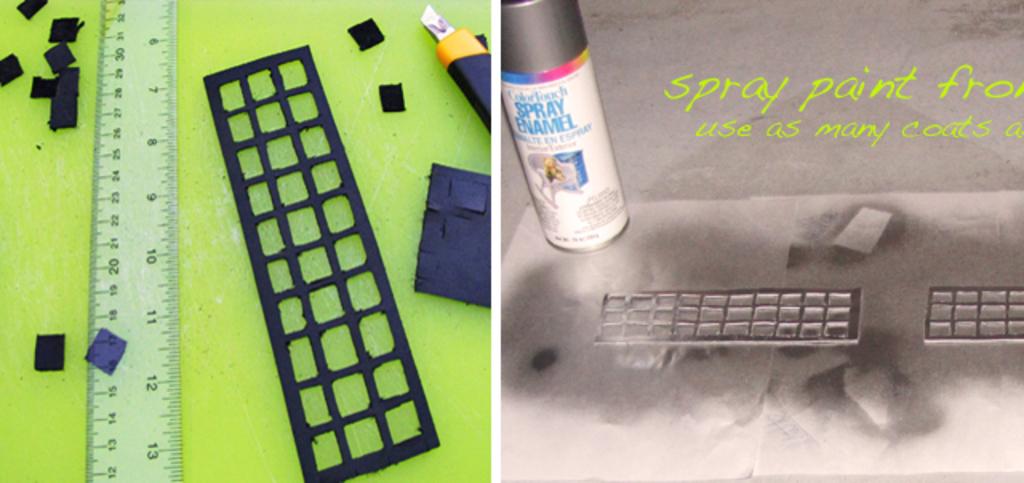What kind of enamel is this?
Provide a succinct answer. Spray. What kind of paint is used?
Offer a very short reply. Spray paint. 